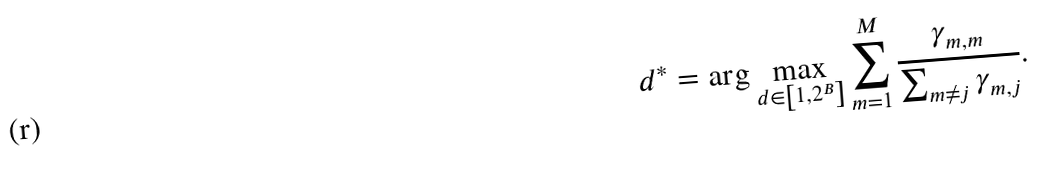<formula> <loc_0><loc_0><loc_500><loc_500>d ^ { * } = \arg \max _ { d \in \left [ 1 , 2 ^ { B } \right ] } \sum _ { m = 1 } ^ { M } { \frac { \gamma _ { m , m } } { \sum _ { m \neq j } \gamma _ { m , j } } } .</formula> 